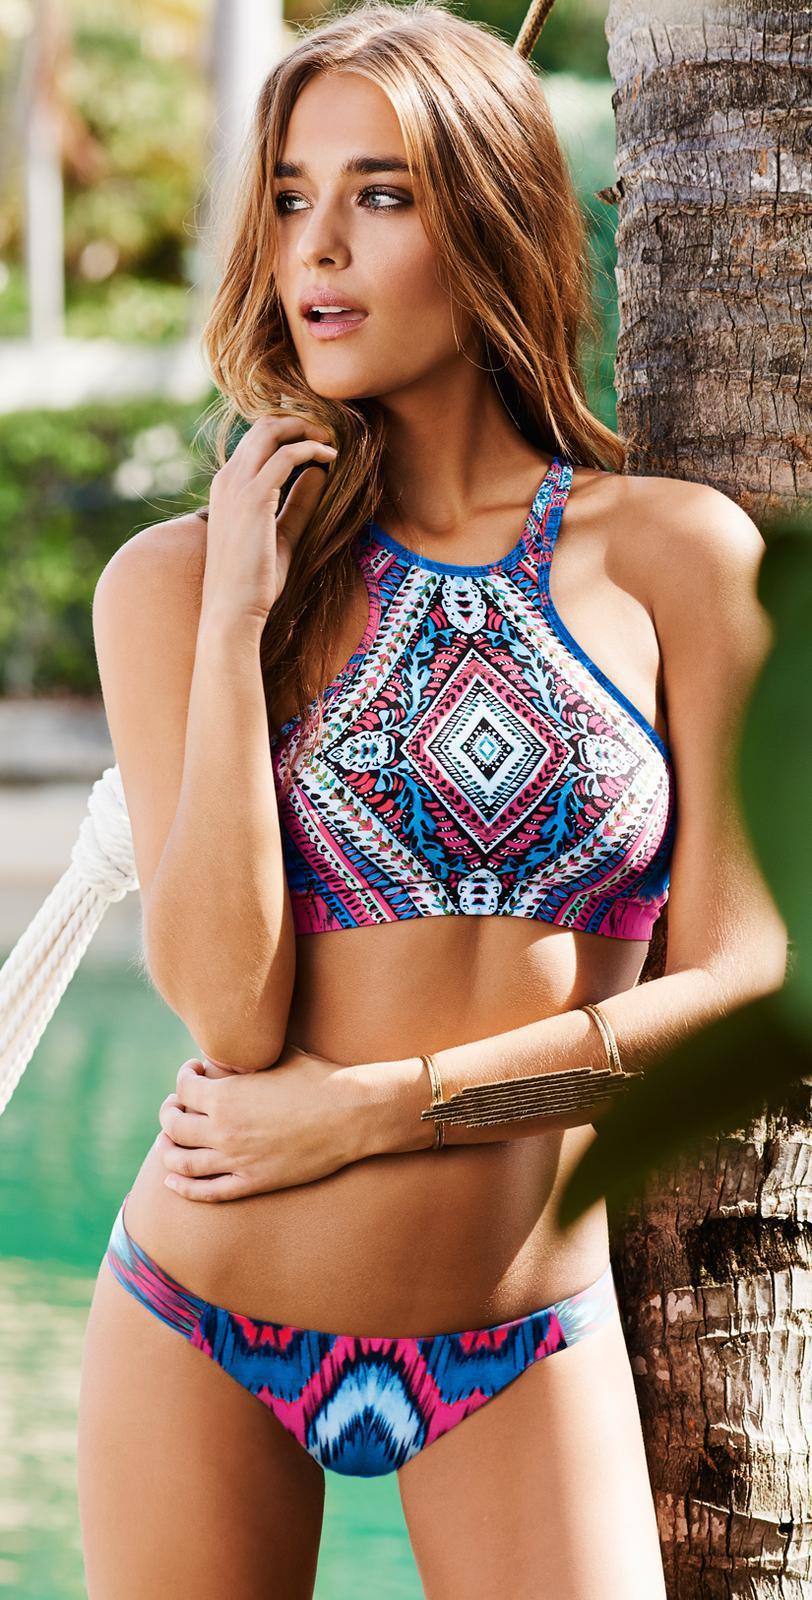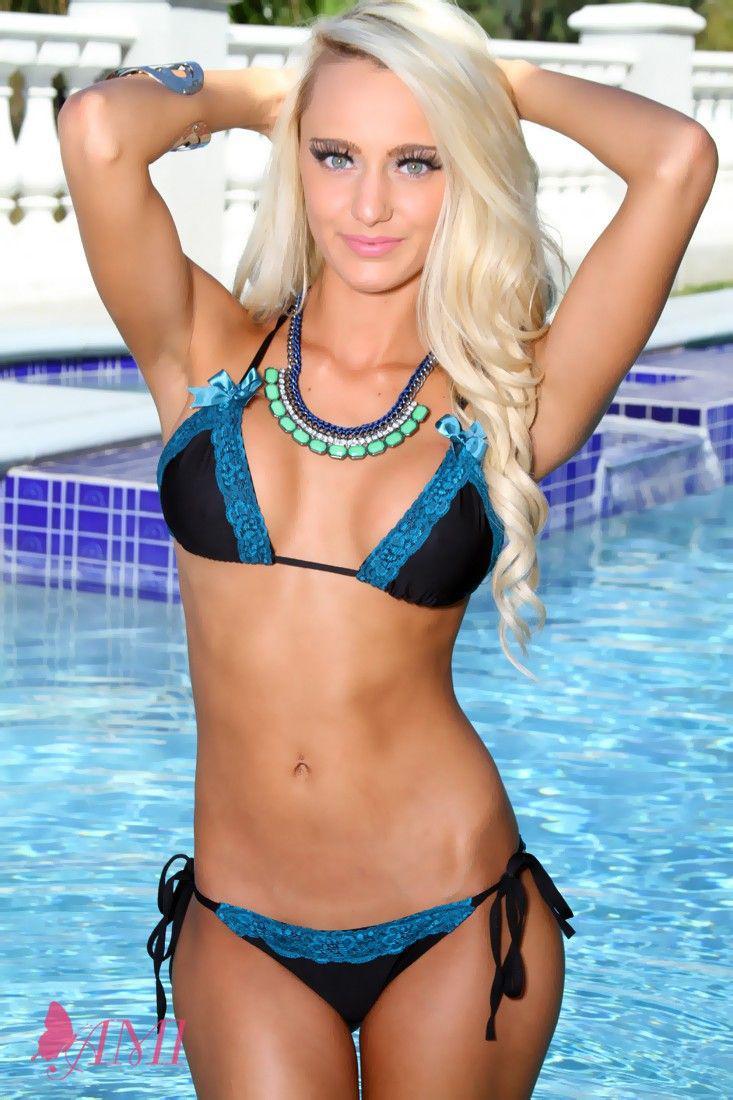The first image is the image on the left, the second image is the image on the right. Considering the images on both sides, is "At least one woman has sunglasses on her head." valid? Answer yes or no. No. 